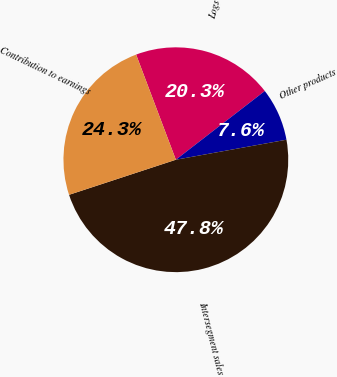Convert chart. <chart><loc_0><loc_0><loc_500><loc_500><pie_chart><fcel>Logs<fcel>Other products<fcel>Intersegment sales<fcel>Contribution to earnings<nl><fcel>20.28%<fcel>7.62%<fcel>47.8%<fcel>24.3%<nl></chart> 